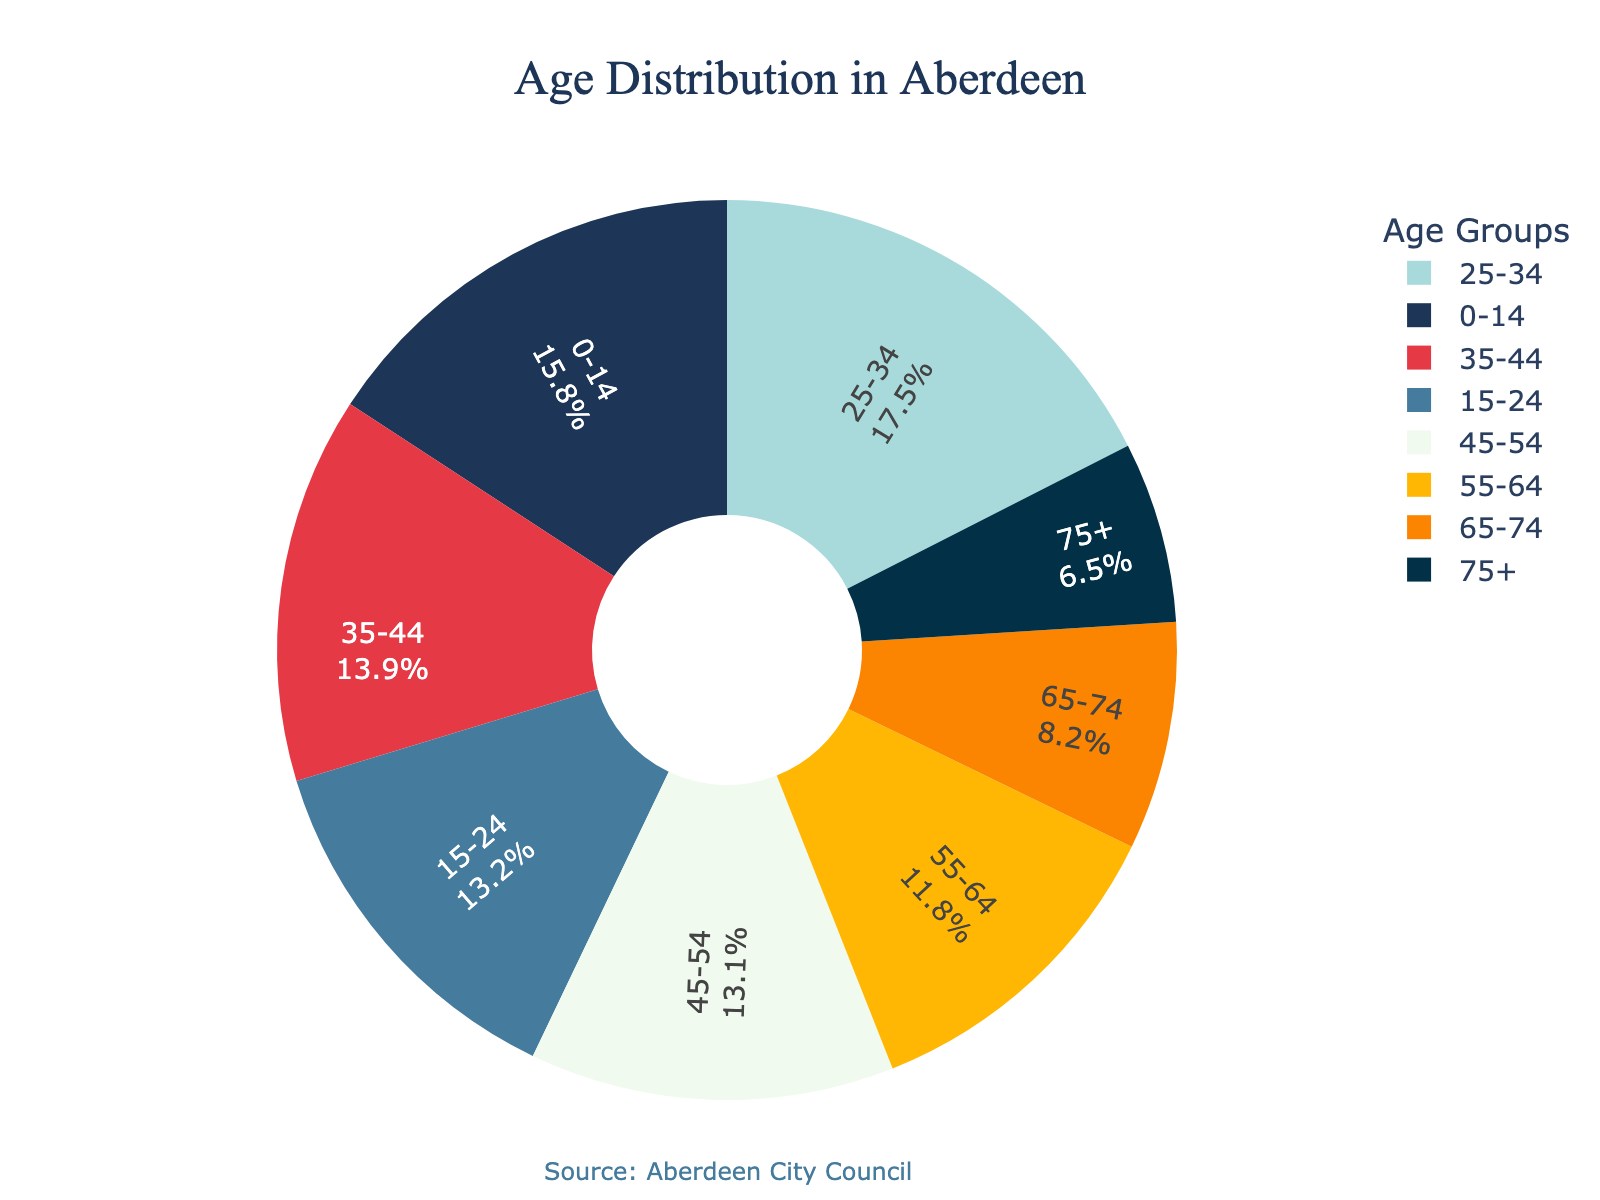Which age group has the largest percentage in Aberdeen? By examining the pie chart, the "25-34" age group segment is visibly the largest, occupying the most space. The percentage is also labeled on the chart as 17.5%.
Answer: 25-34 Which two age groups together account for the highest percentage of the population? By summing the percentages, the "25-34" group (17.5%) and the "0-14" group (15.8%) together account for the highest percentage, which is 17.5 + 15.8 = 33.3%.
Answer: 25-34 and 0-14 What is the total percentage of the population aged 45 and above? Sum the percentages for "45-54" (13.1%), "55-64" (11.8%), "65-74" (8.2%), and "75+" (6.5%). The total is 13.1 + 11.8 + 8.2 + 6.5 = 39.6%.
Answer: 39.6% Which age group has the smallest percentage in Aberdeen? By looking at the segments of the pie chart, the "75+" age group is the smallest, labeled with a percentage of 6.5%.
Answer: 75+ Is the percentage of people aged 35-44 greater than those aged 55-64? The pie chart shows that "35-44" has a percentage of 13.9%, whereas "55-64" has a percentage of 11.8%. Comparing these, 13.9% is greater than 11.8%.
Answer: Yes What is the combined percentage of the age groups from 0-14 and 15-24? Sum the percentages of "0-14" (15.8%) and "15-24" (13.2%). The combined percentage is 15.8 + 13.2 = 29%.
Answer: 29% Which age group segment is represented by the color blue in the pie chart? The pie chart uses a dark blue color for the "0-14" age group segment.
Answer: 0-14 How much smaller is the "75+" age group's percentage compared to the "25-34" group? Subtract the "75+" group's percentage (6.5%) from the "25-34" group's percentage (17.5%). The difference is 17.5 - 6.5 = 11%.
Answer: 11% Is the sum of the percentages of the two smallest age groups greater than 10%? The two smallest age groups are "75+" (6.5%) and "65-74" (8.2%). Summing these gives 6.5 + 8.2 = 14.7%, which is greater than 10%.
Answer: Yes 